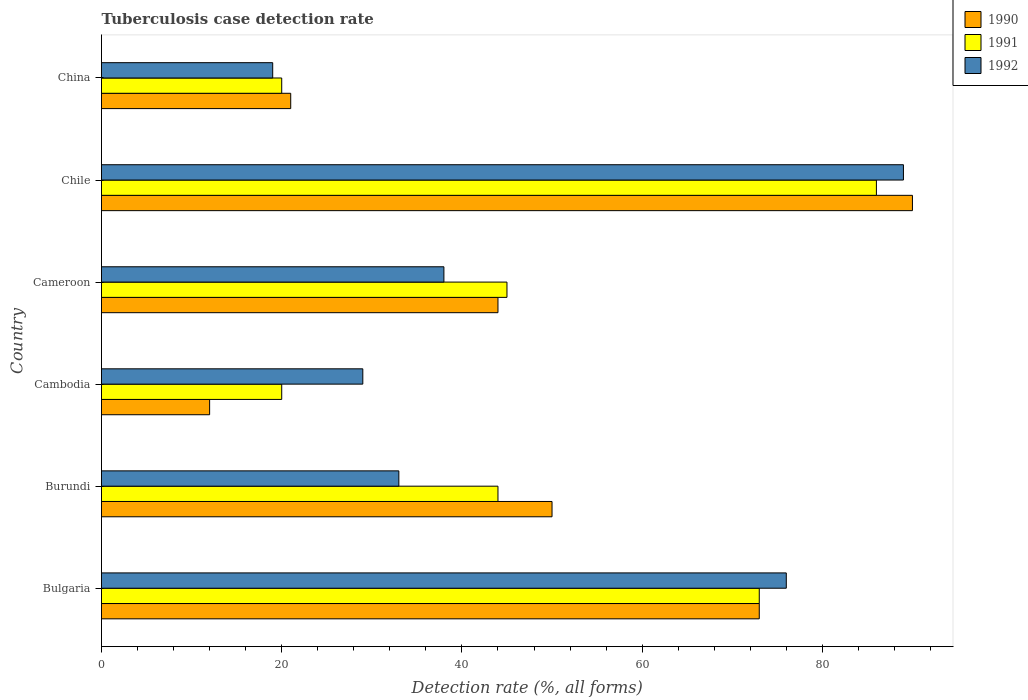How many different coloured bars are there?
Make the answer very short. 3. How many groups of bars are there?
Ensure brevity in your answer.  6. How many bars are there on the 3rd tick from the bottom?
Provide a short and direct response. 3. What is the label of the 5th group of bars from the top?
Provide a succinct answer. Burundi. Across all countries, what is the maximum tuberculosis case detection rate in in 1991?
Give a very brief answer. 86. Across all countries, what is the minimum tuberculosis case detection rate in in 1992?
Give a very brief answer. 19. What is the total tuberculosis case detection rate in in 1991 in the graph?
Offer a very short reply. 288. What is the difference between the tuberculosis case detection rate in in 1990 in Bulgaria and that in Cameroon?
Make the answer very short. 29. What is the average tuberculosis case detection rate in in 1990 per country?
Provide a short and direct response. 48.33. What is the ratio of the tuberculosis case detection rate in in 1992 in Cambodia to that in Cameroon?
Give a very brief answer. 0.76. Is the tuberculosis case detection rate in in 1990 in Burundi less than that in Cameroon?
Keep it short and to the point. No. In how many countries, is the tuberculosis case detection rate in in 1990 greater than the average tuberculosis case detection rate in in 1990 taken over all countries?
Provide a succinct answer. 3. Is the sum of the tuberculosis case detection rate in in 1990 in Burundi and Chile greater than the maximum tuberculosis case detection rate in in 1991 across all countries?
Provide a succinct answer. Yes. How many bars are there?
Give a very brief answer. 18. Are all the bars in the graph horizontal?
Your answer should be very brief. Yes. How many countries are there in the graph?
Your response must be concise. 6. What is the difference between two consecutive major ticks on the X-axis?
Provide a succinct answer. 20. Are the values on the major ticks of X-axis written in scientific E-notation?
Give a very brief answer. No. How many legend labels are there?
Provide a succinct answer. 3. What is the title of the graph?
Offer a terse response. Tuberculosis case detection rate. Does "1974" appear as one of the legend labels in the graph?
Offer a terse response. No. What is the label or title of the X-axis?
Offer a terse response. Detection rate (%, all forms). What is the label or title of the Y-axis?
Make the answer very short. Country. What is the Detection rate (%, all forms) of 1990 in Bulgaria?
Provide a short and direct response. 73. What is the Detection rate (%, all forms) of 1991 in Cameroon?
Provide a succinct answer. 45. What is the Detection rate (%, all forms) of 1992 in Chile?
Provide a succinct answer. 89. What is the Detection rate (%, all forms) of 1990 in China?
Make the answer very short. 21. What is the Detection rate (%, all forms) in 1992 in China?
Your response must be concise. 19. Across all countries, what is the maximum Detection rate (%, all forms) of 1990?
Your answer should be compact. 90. Across all countries, what is the maximum Detection rate (%, all forms) in 1992?
Offer a very short reply. 89. Across all countries, what is the minimum Detection rate (%, all forms) in 1990?
Provide a short and direct response. 12. Across all countries, what is the minimum Detection rate (%, all forms) of 1991?
Make the answer very short. 20. What is the total Detection rate (%, all forms) in 1990 in the graph?
Ensure brevity in your answer.  290. What is the total Detection rate (%, all forms) of 1991 in the graph?
Keep it short and to the point. 288. What is the total Detection rate (%, all forms) in 1992 in the graph?
Make the answer very short. 284. What is the difference between the Detection rate (%, all forms) in 1990 in Bulgaria and that in Burundi?
Offer a very short reply. 23. What is the difference between the Detection rate (%, all forms) in 1990 in Bulgaria and that in Cambodia?
Offer a terse response. 61. What is the difference between the Detection rate (%, all forms) in 1991 in Bulgaria and that in Cambodia?
Offer a terse response. 53. What is the difference between the Detection rate (%, all forms) in 1992 in Bulgaria and that in Cambodia?
Offer a very short reply. 47. What is the difference between the Detection rate (%, all forms) in 1990 in Bulgaria and that in Cameroon?
Offer a very short reply. 29. What is the difference between the Detection rate (%, all forms) of 1992 in Bulgaria and that in Cameroon?
Keep it short and to the point. 38. What is the difference between the Detection rate (%, all forms) in 1991 in Bulgaria and that in Chile?
Make the answer very short. -13. What is the difference between the Detection rate (%, all forms) in 1992 in Bulgaria and that in Chile?
Your answer should be compact. -13. What is the difference between the Detection rate (%, all forms) of 1991 in Bulgaria and that in China?
Your answer should be compact. 53. What is the difference between the Detection rate (%, all forms) in 1992 in Bulgaria and that in China?
Offer a very short reply. 57. What is the difference between the Detection rate (%, all forms) in 1990 in Burundi and that in Cambodia?
Your response must be concise. 38. What is the difference between the Detection rate (%, all forms) in 1991 in Burundi and that in Cambodia?
Provide a succinct answer. 24. What is the difference between the Detection rate (%, all forms) in 1992 in Burundi and that in Cambodia?
Provide a short and direct response. 4. What is the difference between the Detection rate (%, all forms) in 1990 in Burundi and that in Cameroon?
Make the answer very short. 6. What is the difference between the Detection rate (%, all forms) of 1992 in Burundi and that in Cameroon?
Keep it short and to the point. -5. What is the difference between the Detection rate (%, all forms) of 1991 in Burundi and that in Chile?
Keep it short and to the point. -42. What is the difference between the Detection rate (%, all forms) in 1992 in Burundi and that in Chile?
Your answer should be very brief. -56. What is the difference between the Detection rate (%, all forms) of 1990 in Burundi and that in China?
Offer a terse response. 29. What is the difference between the Detection rate (%, all forms) of 1991 in Burundi and that in China?
Provide a short and direct response. 24. What is the difference between the Detection rate (%, all forms) of 1990 in Cambodia and that in Cameroon?
Your answer should be compact. -32. What is the difference between the Detection rate (%, all forms) in 1990 in Cambodia and that in Chile?
Give a very brief answer. -78. What is the difference between the Detection rate (%, all forms) of 1991 in Cambodia and that in Chile?
Offer a terse response. -66. What is the difference between the Detection rate (%, all forms) in 1992 in Cambodia and that in Chile?
Offer a terse response. -60. What is the difference between the Detection rate (%, all forms) of 1990 in Cambodia and that in China?
Offer a terse response. -9. What is the difference between the Detection rate (%, all forms) in 1991 in Cambodia and that in China?
Make the answer very short. 0. What is the difference between the Detection rate (%, all forms) in 1990 in Cameroon and that in Chile?
Offer a terse response. -46. What is the difference between the Detection rate (%, all forms) in 1991 in Cameroon and that in Chile?
Provide a succinct answer. -41. What is the difference between the Detection rate (%, all forms) in 1992 in Cameroon and that in Chile?
Give a very brief answer. -51. What is the difference between the Detection rate (%, all forms) of 1990 in Cameroon and that in China?
Make the answer very short. 23. What is the difference between the Detection rate (%, all forms) of 1992 in Cameroon and that in China?
Give a very brief answer. 19. What is the difference between the Detection rate (%, all forms) of 1991 in Chile and that in China?
Your answer should be very brief. 66. What is the difference between the Detection rate (%, all forms) of 1990 in Bulgaria and the Detection rate (%, all forms) of 1992 in Burundi?
Provide a short and direct response. 40. What is the difference between the Detection rate (%, all forms) of 1991 in Bulgaria and the Detection rate (%, all forms) of 1992 in Burundi?
Ensure brevity in your answer.  40. What is the difference between the Detection rate (%, all forms) of 1990 in Bulgaria and the Detection rate (%, all forms) of 1992 in Cambodia?
Offer a very short reply. 44. What is the difference between the Detection rate (%, all forms) of 1991 in Bulgaria and the Detection rate (%, all forms) of 1992 in Cambodia?
Give a very brief answer. 44. What is the difference between the Detection rate (%, all forms) in 1990 in Bulgaria and the Detection rate (%, all forms) in 1992 in Cameroon?
Your answer should be very brief. 35. What is the difference between the Detection rate (%, all forms) in 1991 in Bulgaria and the Detection rate (%, all forms) in 1992 in Cameroon?
Provide a short and direct response. 35. What is the difference between the Detection rate (%, all forms) of 1990 in Bulgaria and the Detection rate (%, all forms) of 1991 in Chile?
Provide a succinct answer. -13. What is the difference between the Detection rate (%, all forms) of 1991 in Bulgaria and the Detection rate (%, all forms) of 1992 in Chile?
Make the answer very short. -16. What is the difference between the Detection rate (%, all forms) of 1990 in Bulgaria and the Detection rate (%, all forms) of 1991 in China?
Provide a succinct answer. 53. What is the difference between the Detection rate (%, all forms) in 1991 in Bulgaria and the Detection rate (%, all forms) in 1992 in China?
Your answer should be compact. 54. What is the difference between the Detection rate (%, all forms) in 1990 in Burundi and the Detection rate (%, all forms) in 1991 in Cameroon?
Offer a very short reply. 5. What is the difference between the Detection rate (%, all forms) in 1991 in Burundi and the Detection rate (%, all forms) in 1992 in Cameroon?
Provide a succinct answer. 6. What is the difference between the Detection rate (%, all forms) in 1990 in Burundi and the Detection rate (%, all forms) in 1991 in Chile?
Offer a very short reply. -36. What is the difference between the Detection rate (%, all forms) of 1990 in Burundi and the Detection rate (%, all forms) of 1992 in Chile?
Make the answer very short. -39. What is the difference between the Detection rate (%, all forms) of 1991 in Burundi and the Detection rate (%, all forms) of 1992 in Chile?
Offer a very short reply. -45. What is the difference between the Detection rate (%, all forms) of 1990 in Burundi and the Detection rate (%, all forms) of 1991 in China?
Offer a very short reply. 30. What is the difference between the Detection rate (%, all forms) in 1990 in Burundi and the Detection rate (%, all forms) in 1992 in China?
Ensure brevity in your answer.  31. What is the difference between the Detection rate (%, all forms) of 1990 in Cambodia and the Detection rate (%, all forms) of 1991 in Cameroon?
Your answer should be very brief. -33. What is the difference between the Detection rate (%, all forms) of 1990 in Cambodia and the Detection rate (%, all forms) of 1992 in Cameroon?
Your response must be concise. -26. What is the difference between the Detection rate (%, all forms) in 1991 in Cambodia and the Detection rate (%, all forms) in 1992 in Cameroon?
Make the answer very short. -18. What is the difference between the Detection rate (%, all forms) of 1990 in Cambodia and the Detection rate (%, all forms) of 1991 in Chile?
Provide a short and direct response. -74. What is the difference between the Detection rate (%, all forms) of 1990 in Cambodia and the Detection rate (%, all forms) of 1992 in Chile?
Keep it short and to the point. -77. What is the difference between the Detection rate (%, all forms) in 1991 in Cambodia and the Detection rate (%, all forms) in 1992 in Chile?
Keep it short and to the point. -69. What is the difference between the Detection rate (%, all forms) of 1991 in Cambodia and the Detection rate (%, all forms) of 1992 in China?
Your answer should be very brief. 1. What is the difference between the Detection rate (%, all forms) in 1990 in Cameroon and the Detection rate (%, all forms) in 1991 in Chile?
Give a very brief answer. -42. What is the difference between the Detection rate (%, all forms) of 1990 in Cameroon and the Detection rate (%, all forms) of 1992 in Chile?
Keep it short and to the point. -45. What is the difference between the Detection rate (%, all forms) of 1991 in Cameroon and the Detection rate (%, all forms) of 1992 in Chile?
Offer a terse response. -44. What is the difference between the Detection rate (%, all forms) in 1990 in Chile and the Detection rate (%, all forms) in 1991 in China?
Offer a terse response. 70. What is the difference between the Detection rate (%, all forms) in 1991 in Chile and the Detection rate (%, all forms) in 1992 in China?
Offer a terse response. 67. What is the average Detection rate (%, all forms) in 1990 per country?
Provide a short and direct response. 48.33. What is the average Detection rate (%, all forms) of 1992 per country?
Keep it short and to the point. 47.33. What is the difference between the Detection rate (%, all forms) in 1990 and Detection rate (%, all forms) in 1991 in Bulgaria?
Your response must be concise. 0. What is the difference between the Detection rate (%, all forms) of 1990 and Detection rate (%, all forms) of 1991 in Burundi?
Give a very brief answer. 6. What is the difference between the Detection rate (%, all forms) in 1991 and Detection rate (%, all forms) in 1992 in Burundi?
Offer a very short reply. 11. What is the difference between the Detection rate (%, all forms) of 1990 and Detection rate (%, all forms) of 1992 in Cameroon?
Ensure brevity in your answer.  6. What is the difference between the Detection rate (%, all forms) of 1990 and Detection rate (%, all forms) of 1991 in Chile?
Offer a terse response. 4. What is the difference between the Detection rate (%, all forms) in 1990 and Detection rate (%, all forms) in 1991 in China?
Make the answer very short. 1. What is the difference between the Detection rate (%, all forms) in 1990 and Detection rate (%, all forms) in 1992 in China?
Your response must be concise. 2. What is the difference between the Detection rate (%, all forms) of 1991 and Detection rate (%, all forms) of 1992 in China?
Ensure brevity in your answer.  1. What is the ratio of the Detection rate (%, all forms) in 1990 in Bulgaria to that in Burundi?
Keep it short and to the point. 1.46. What is the ratio of the Detection rate (%, all forms) of 1991 in Bulgaria to that in Burundi?
Give a very brief answer. 1.66. What is the ratio of the Detection rate (%, all forms) of 1992 in Bulgaria to that in Burundi?
Offer a terse response. 2.3. What is the ratio of the Detection rate (%, all forms) in 1990 in Bulgaria to that in Cambodia?
Give a very brief answer. 6.08. What is the ratio of the Detection rate (%, all forms) in 1991 in Bulgaria to that in Cambodia?
Provide a short and direct response. 3.65. What is the ratio of the Detection rate (%, all forms) in 1992 in Bulgaria to that in Cambodia?
Keep it short and to the point. 2.62. What is the ratio of the Detection rate (%, all forms) in 1990 in Bulgaria to that in Cameroon?
Ensure brevity in your answer.  1.66. What is the ratio of the Detection rate (%, all forms) of 1991 in Bulgaria to that in Cameroon?
Make the answer very short. 1.62. What is the ratio of the Detection rate (%, all forms) of 1990 in Bulgaria to that in Chile?
Your answer should be compact. 0.81. What is the ratio of the Detection rate (%, all forms) of 1991 in Bulgaria to that in Chile?
Give a very brief answer. 0.85. What is the ratio of the Detection rate (%, all forms) in 1992 in Bulgaria to that in Chile?
Your answer should be compact. 0.85. What is the ratio of the Detection rate (%, all forms) of 1990 in Bulgaria to that in China?
Keep it short and to the point. 3.48. What is the ratio of the Detection rate (%, all forms) of 1991 in Bulgaria to that in China?
Keep it short and to the point. 3.65. What is the ratio of the Detection rate (%, all forms) in 1992 in Bulgaria to that in China?
Your answer should be very brief. 4. What is the ratio of the Detection rate (%, all forms) of 1990 in Burundi to that in Cambodia?
Your response must be concise. 4.17. What is the ratio of the Detection rate (%, all forms) in 1991 in Burundi to that in Cambodia?
Your answer should be compact. 2.2. What is the ratio of the Detection rate (%, all forms) in 1992 in Burundi to that in Cambodia?
Your response must be concise. 1.14. What is the ratio of the Detection rate (%, all forms) of 1990 in Burundi to that in Cameroon?
Offer a very short reply. 1.14. What is the ratio of the Detection rate (%, all forms) in 1991 in Burundi to that in Cameroon?
Offer a very short reply. 0.98. What is the ratio of the Detection rate (%, all forms) of 1992 in Burundi to that in Cameroon?
Give a very brief answer. 0.87. What is the ratio of the Detection rate (%, all forms) in 1990 in Burundi to that in Chile?
Make the answer very short. 0.56. What is the ratio of the Detection rate (%, all forms) in 1991 in Burundi to that in Chile?
Give a very brief answer. 0.51. What is the ratio of the Detection rate (%, all forms) of 1992 in Burundi to that in Chile?
Provide a short and direct response. 0.37. What is the ratio of the Detection rate (%, all forms) of 1990 in Burundi to that in China?
Provide a short and direct response. 2.38. What is the ratio of the Detection rate (%, all forms) of 1992 in Burundi to that in China?
Your response must be concise. 1.74. What is the ratio of the Detection rate (%, all forms) of 1990 in Cambodia to that in Cameroon?
Provide a short and direct response. 0.27. What is the ratio of the Detection rate (%, all forms) of 1991 in Cambodia to that in Cameroon?
Give a very brief answer. 0.44. What is the ratio of the Detection rate (%, all forms) in 1992 in Cambodia to that in Cameroon?
Your answer should be very brief. 0.76. What is the ratio of the Detection rate (%, all forms) in 1990 in Cambodia to that in Chile?
Offer a very short reply. 0.13. What is the ratio of the Detection rate (%, all forms) of 1991 in Cambodia to that in Chile?
Offer a terse response. 0.23. What is the ratio of the Detection rate (%, all forms) in 1992 in Cambodia to that in Chile?
Your response must be concise. 0.33. What is the ratio of the Detection rate (%, all forms) in 1992 in Cambodia to that in China?
Ensure brevity in your answer.  1.53. What is the ratio of the Detection rate (%, all forms) of 1990 in Cameroon to that in Chile?
Your answer should be very brief. 0.49. What is the ratio of the Detection rate (%, all forms) of 1991 in Cameroon to that in Chile?
Ensure brevity in your answer.  0.52. What is the ratio of the Detection rate (%, all forms) of 1992 in Cameroon to that in Chile?
Make the answer very short. 0.43. What is the ratio of the Detection rate (%, all forms) in 1990 in Cameroon to that in China?
Your answer should be compact. 2.1. What is the ratio of the Detection rate (%, all forms) of 1991 in Cameroon to that in China?
Your response must be concise. 2.25. What is the ratio of the Detection rate (%, all forms) of 1992 in Cameroon to that in China?
Make the answer very short. 2. What is the ratio of the Detection rate (%, all forms) in 1990 in Chile to that in China?
Offer a terse response. 4.29. What is the ratio of the Detection rate (%, all forms) in 1992 in Chile to that in China?
Give a very brief answer. 4.68. What is the difference between the highest and the second highest Detection rate (%, all forms) in 1990?
Keep it short and to the point. 17. What is the difference between the highest and the second highest Detection rate (%, all forms) of 1991?
Make the answer very short. 13. What is the difference between the highest and the second highest Detection rate (%, all forms) of 1992?
Keep it short and to the point. 13. What is the difference between the highest and the lowest Detection rate (%, all forms) of 1991?
Keep it short and to the point. 66. 